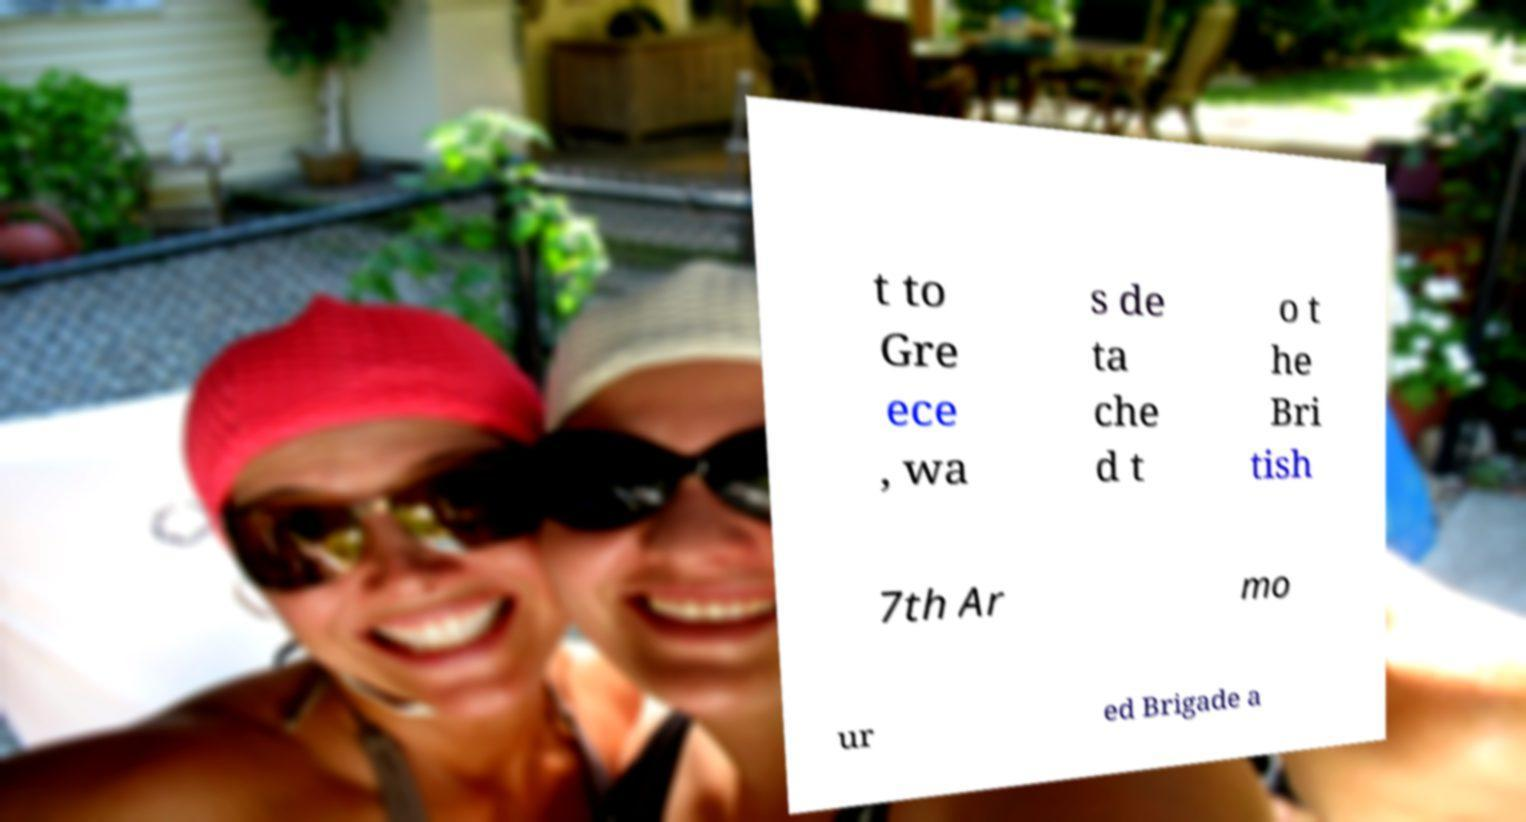Can you read and provide the text displayed in the image?This photo seems to have some interesting text. Can you extract and type it out for me? t to Gre ece , wa s de ta che d t o t he Bri tish 7th Ar mo ur ed Brigade a 